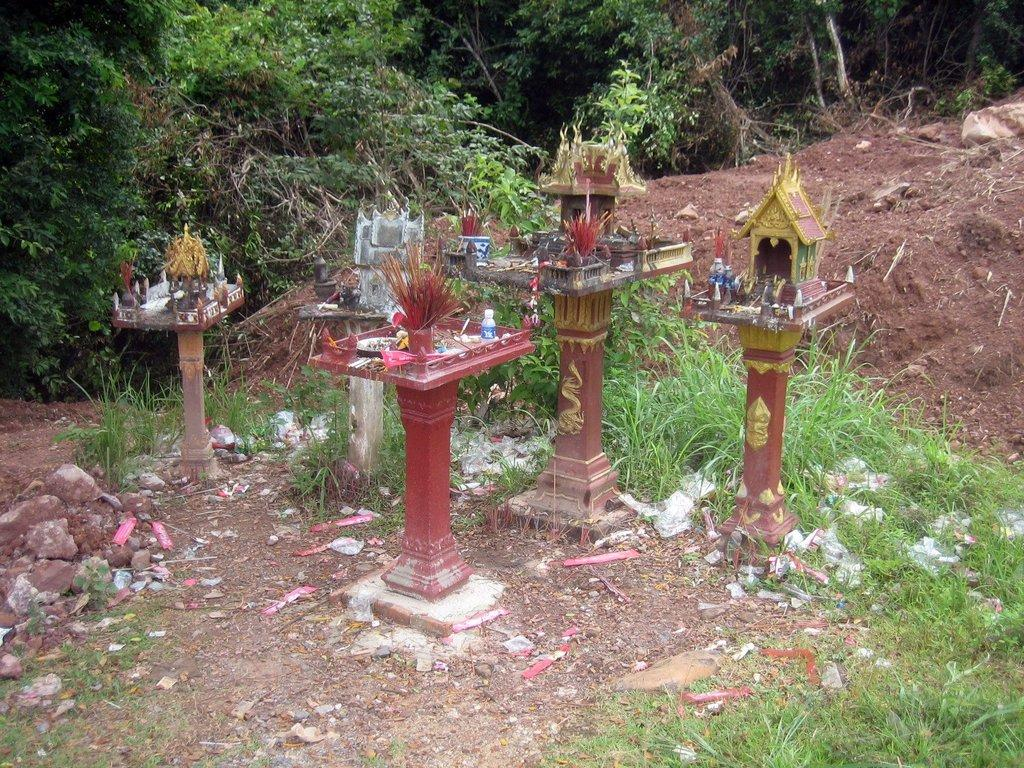What is located in the center of the image? There are pillars and baskets in the center of the image. What type of surface is at the bottom of the image? There is grass and sand at the bottom of the image. What can be seen in the background of the image? There are trees and sand in the background of the image. What type of fabric is used to make the pillows in the image? There are no pillows present in the image; it features pillars and baskets. What type of material is the sweater made of that the trees are wearing in the background? There are no sweaters or trees wearing clothing in the image. 